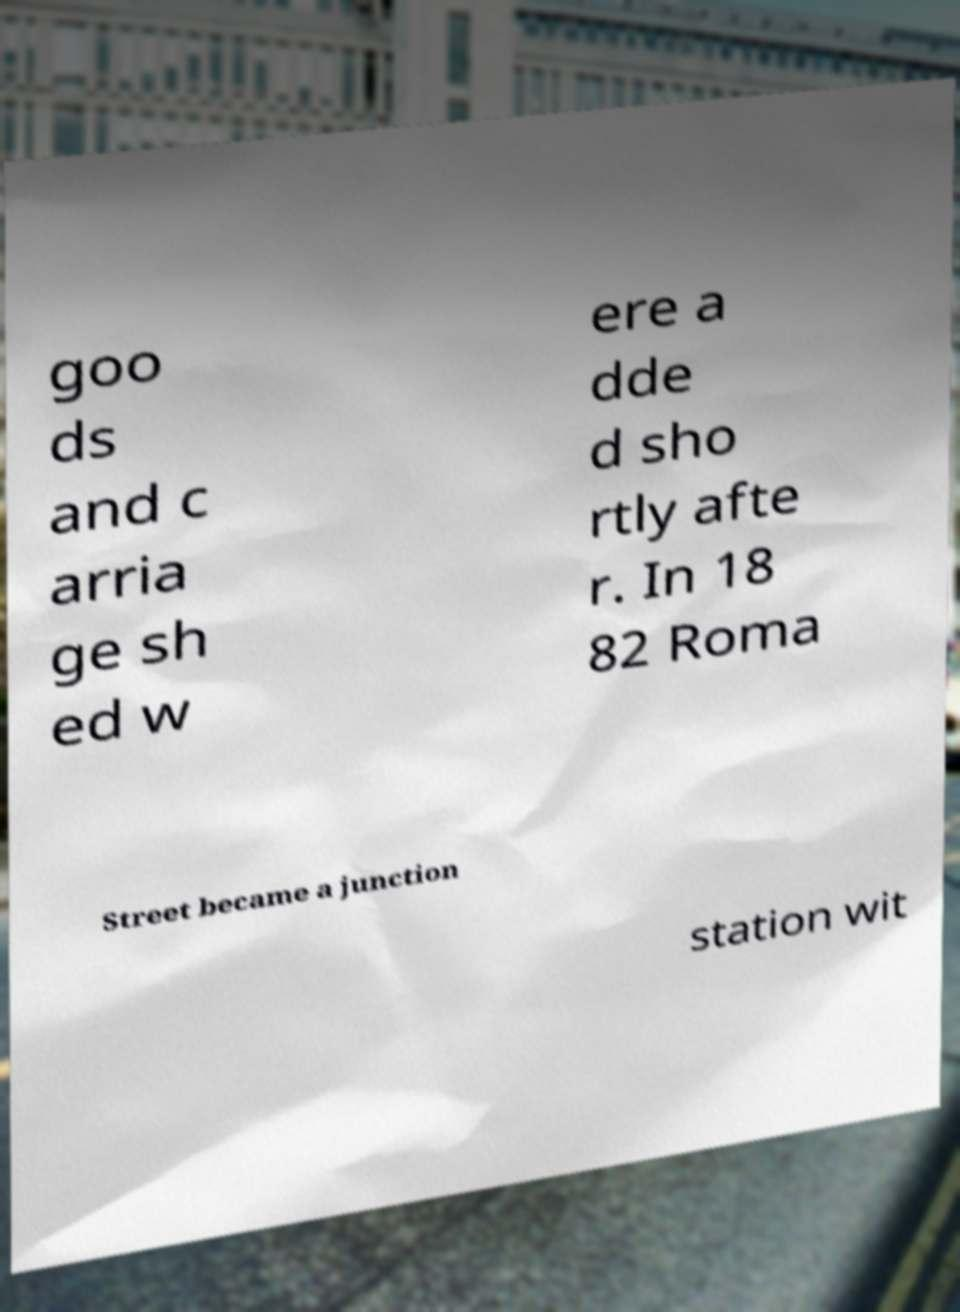For documentation purposes, I need the text within this image transcribed. Could you provide that? goo ds and c arria ge sh ed w ere a dde d sho rtly afte r. In 18 82 Roma Street became a junction station wit 